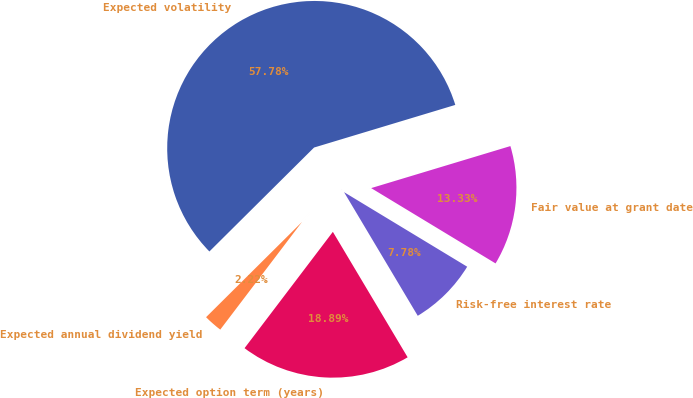Convert chart. <chart><loc_0><loc_0><loc_500><loc_500><pie_chart><fcel>Expected volatility<fcel>Expected annual dividend yield<fcel>Expected option term (years)<fcel>Risk-free interest rate<fcel>Fair value at grant date<nl><fcel>57.78%<fcel>2.22%<fcel>18.89%<fcel>7.78%<fcel>13.33%<nl></chart> 